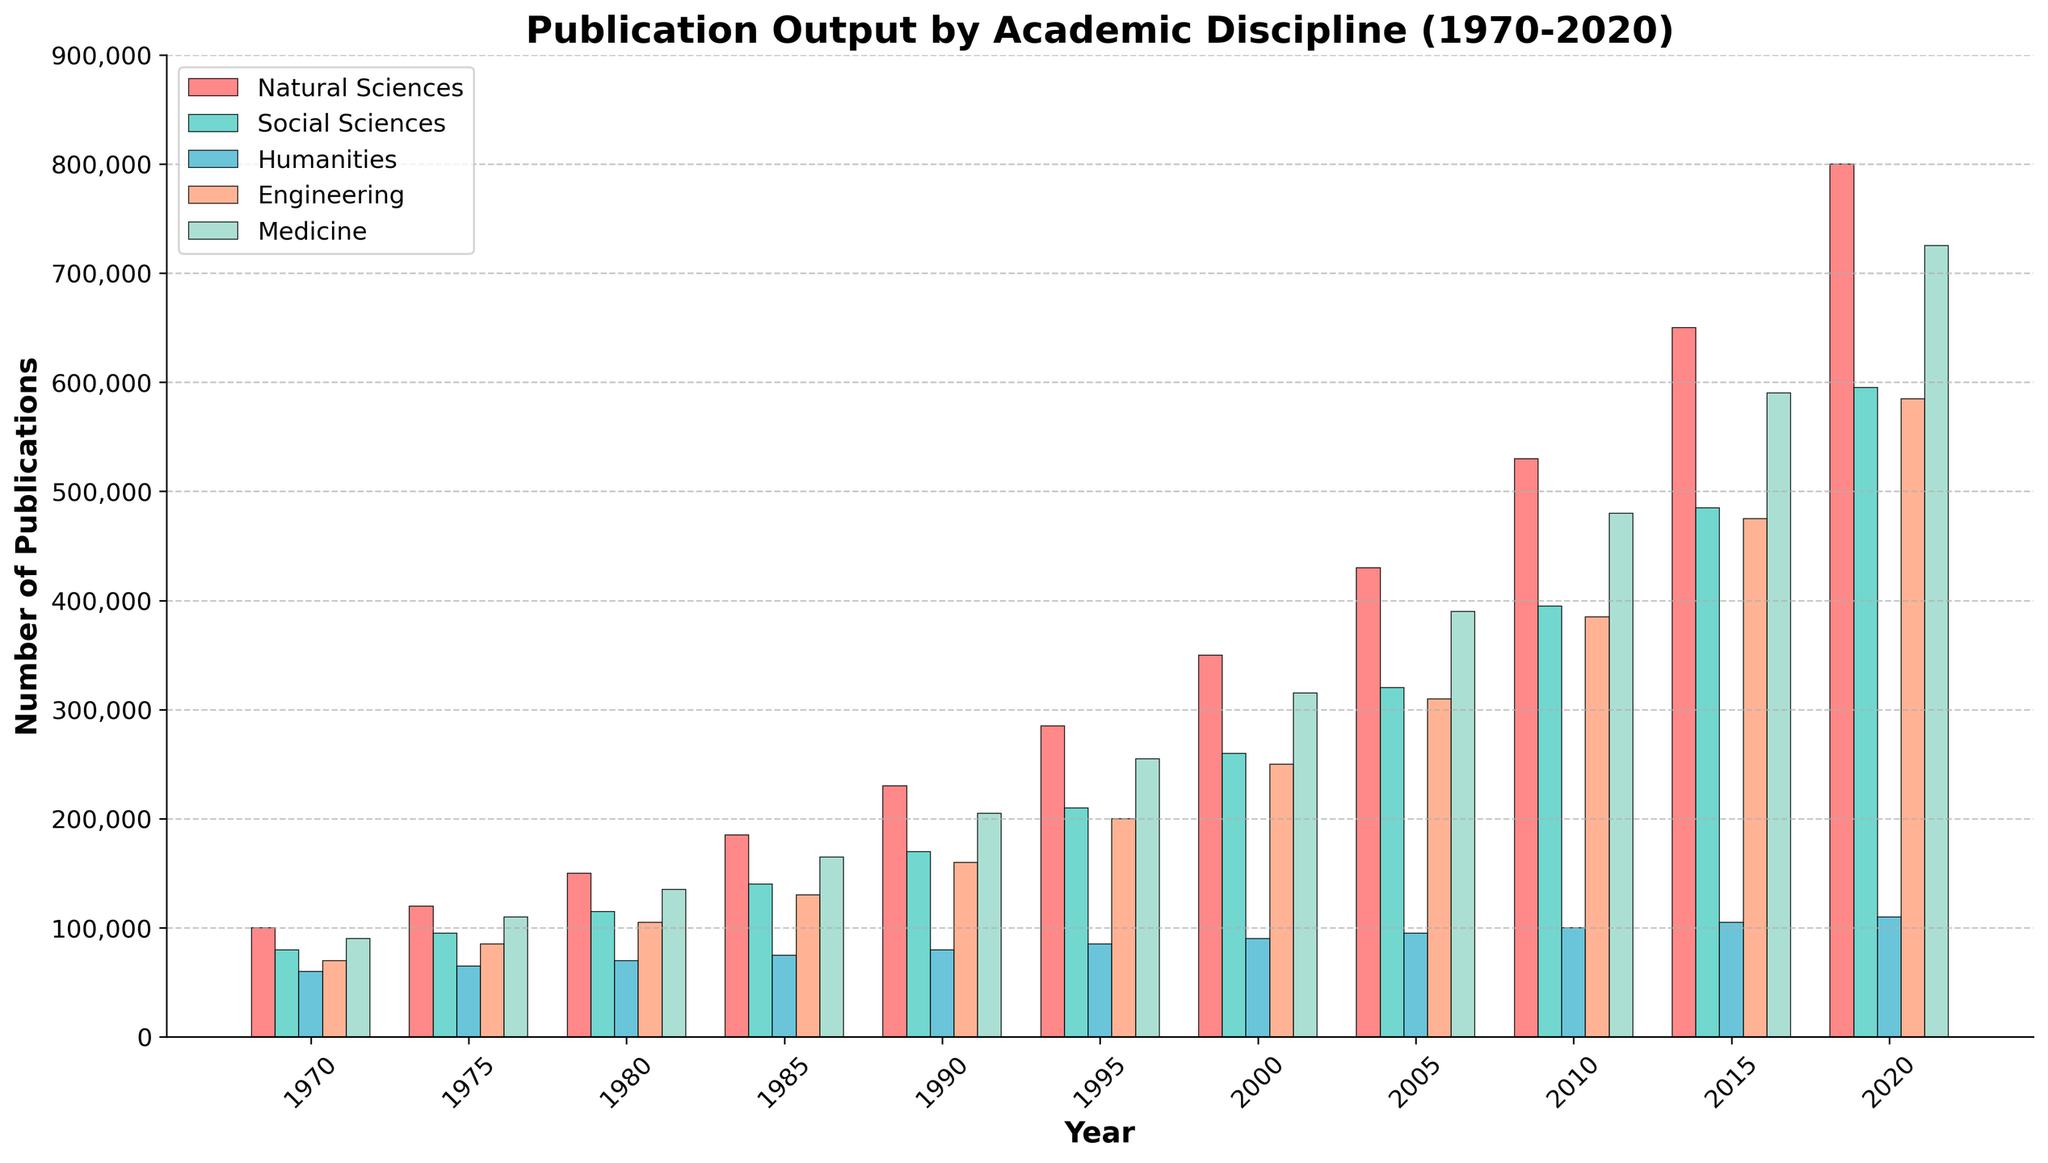What's the publication output for Humanities in 1980? Look at the bar representing 1980 and find the height for 'Humanities', which is around 70,000.
Answer: 70,000 Comparing Engineering and Social Sciences in 2020, which discipline had more publications? In 2020, the bar for Engineering is higher than that for Social Sciences. The numbers are 585,000 for Engineering and 595,000 for Social Sciences.
Answer: Social Sciences What is the overall trend in publication output for Medicine from 1970 to 2020? Starting from 1970, the publication count for Medicine consistently increases from 90,000 to 725,000 in 2020, indicating a significant upward trend.
Answer: Upward trend How much did the publication output for Natural Sciences increase from 1970 to 2020? In 1970, the output was 100,000 and in 2020 it was 800,000. The increase is 800,000 - 100,000 = 700,000.
Answer: 700,000 What is the difference in publication output between Humanities and Engineering in 2005? In 2005, Humanities had 95,000 publications and Engineering had 310,000. The difference is 310,000 - 95,000 = 215,000.
Answer: 215,000 What was the average publication output for Natural Sciences and Social Sciences in 1985? In 1985, Natural Sciences had 185,000 and Social Sciences had 140,000. The average is (185,000 + 140,000) / 2 = 162,500.
Answer: 162,500 In which year did the Social Sciences first surpass 400,000 publications? The bar for Social Sciences first exceeds 400,000 in 2010, with 395,000 publications. The next recorded value is 485,000 in 2015.
Answer: 2015 How many more publications were there in Medicine than in Humanities in 2015? In 2015, Medicine had 590,000 publications and Humanities had 105,000. The difference is 590,000 - 105,000 = 485,000.
Answer: 485,000 Which discipline had the largest increase in publication output from 2015 to 2020? From 2015 to 2020, Medicine increased from 590,000 to 725,000, a difference of 135,000. Natural Sciences from 650,000 to 800,000, a difference of 150,000; Social Sciences from 485,000 to 595,000, a difference of 110,000; Humanities from 105,000 to 110,000, a difference of 5,000; and Engineering from 475,000 to 585,000, a difference of 110,000. The largest increase is seen in Natural Sciences.
Answer: Natural Sciences Which discipline maintained the most consistent growth rate over 50 years? Analyzing all bars over time, Natural Sciences show the most consistent incremental increase without drastic fluctuations from 100,000 in 1970 to 800,000 in 2020.
Answer: Natural Sciences 